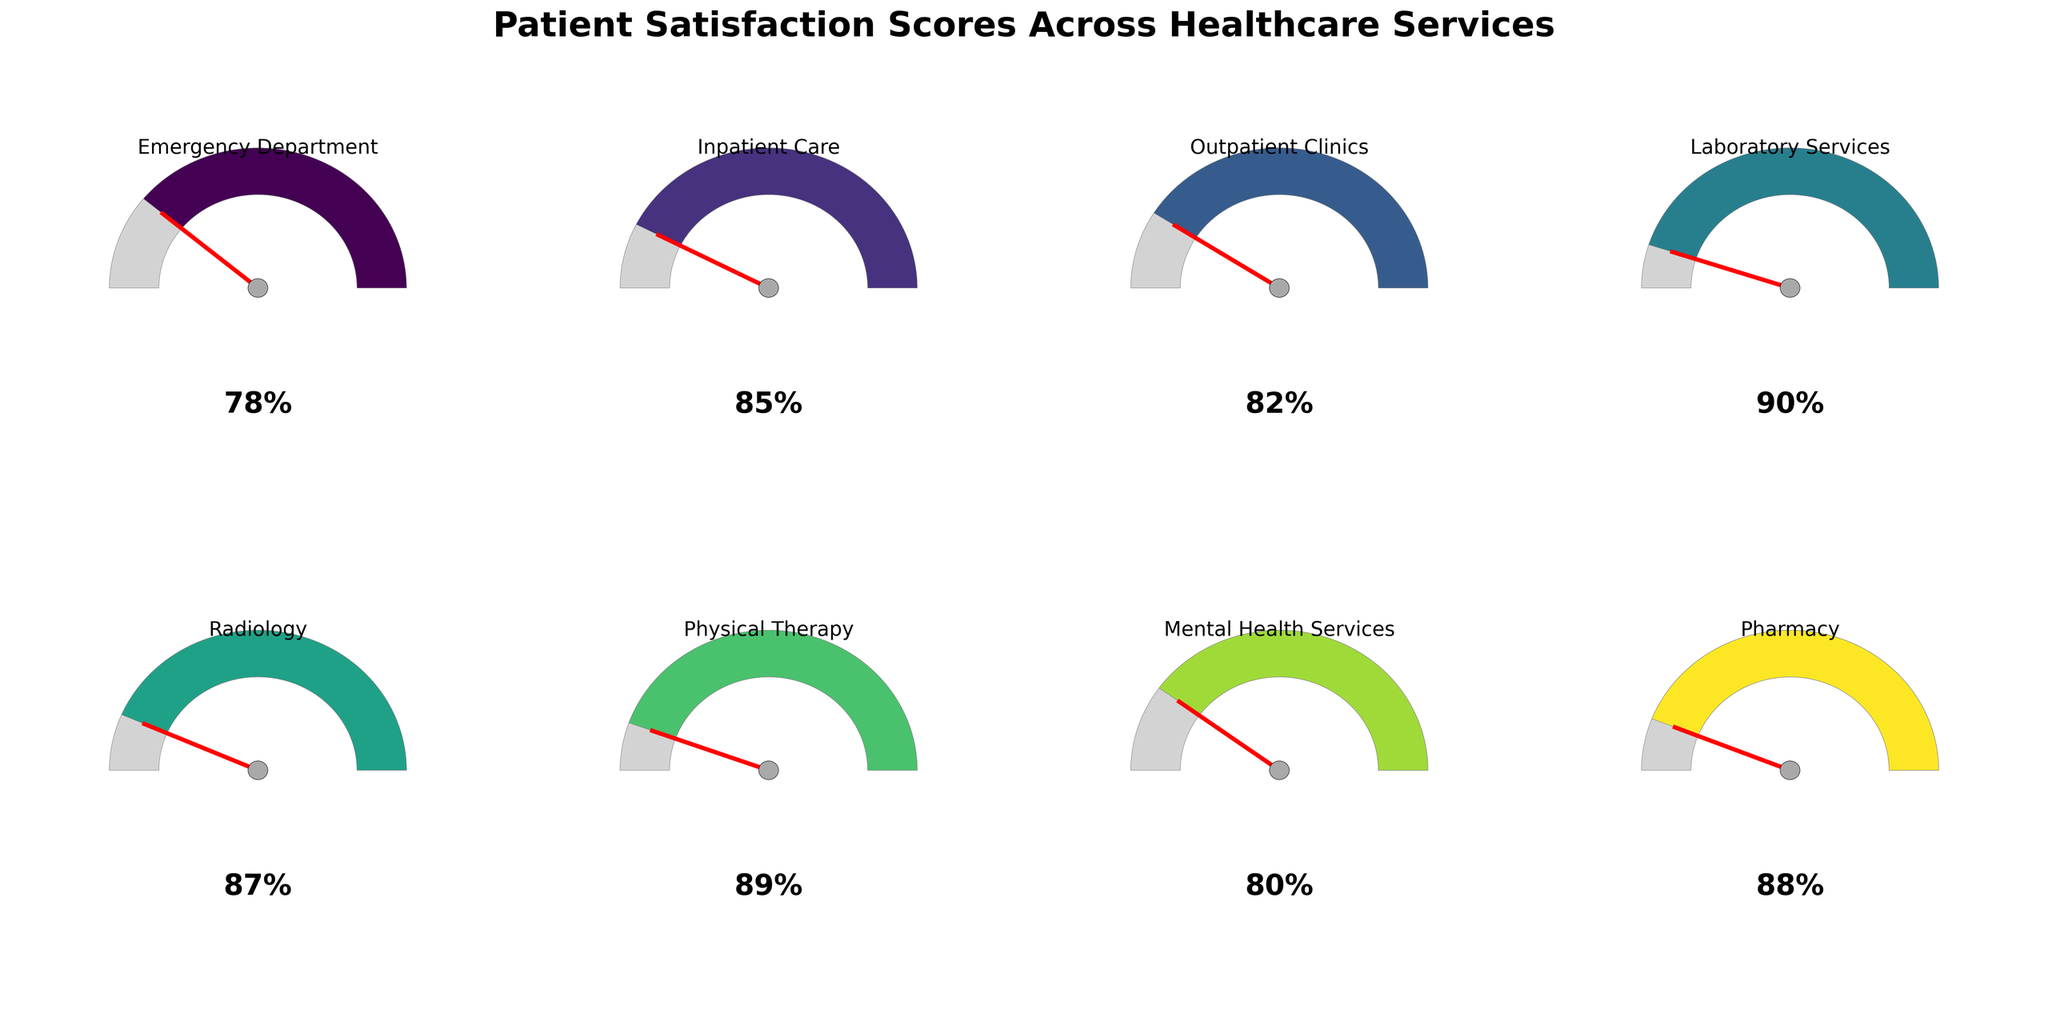Which healthcare service has the highest patient satisfaction score? By comparing the satisfaction scores across the different healthcare services in the figure, we can see that Laboratory Services has the highest score, with 90%.
Answer: Laboratory Services Which healthcare service has the lowest patient satisfaction score? The Emergency Department has the lowest satisfaction score of 78% when we compare it with the other healthcare services in the figure.
Answer: Emergency Department What is the average patient satisfaction score across all healthcare services? Sum all the satisfaction scores and divide by the number of services: (78 + 85 + 82 + 90 + 87 + 89 + 80 + 88) / 8 = 84.875
Answer: 84.88 How much higher is the satisfaction score for Pharmacy compared to Mental Health Services? Pharmacy has a satisfaction score of 88%, and Mental Health Services has 80%. Hence, 88 - 80 = 8%.
Answer: 8% Which services have a patient satisfaction score above 85%? By examining the figure, the services with scores above 85% are Inpatient Care (85%), Laboratory Services (90%), Radiology (87%), Physical Therapy (89%), and Pharmacy (88%).
Answer: Inpatient Care, Laboratory Services, Radiology, Physical Therapy, Pharmacy What is the median satisfaction score among all healthcare services? To find the median, list the scores in ascending order: 78, 80, 82, 85, 87, 88, 89, 90. The median is the average of the 4th and 5th values: (85 + 87) / 2 = 86%.
Answer: 86% Is the satisfaction score for Outpatient Clinics above or below the overall average satisfaction score? The overall average score is 84.875. Outpatient Clinics has a score of 82%, which is below the average.
Answer: Below What is the range of satisfaction scores across the different healthcare services? The range is calculated as the difference between the highest and lowest scores: 90% (Laboratory Services) - 78% (Emergency Department) = 12%.
Answer: 12% Compare the satisfaction scores between Radiology and Physical Therapy. Which one is higher? Radiology has a satisfaction score of 87%, and Physical Therapy has a score of 89%. Therefore, Physical Therapy has a higher satisfaction score.
Answer: Physical Therapy What percentage of the services have a satisfaction score of 85% or higher? There are 5 services out of 8 with a satisfaction score of 85% or higher. The percentage is (5 / 8) * 100 = 62.5%.
Answer: 62.5% 